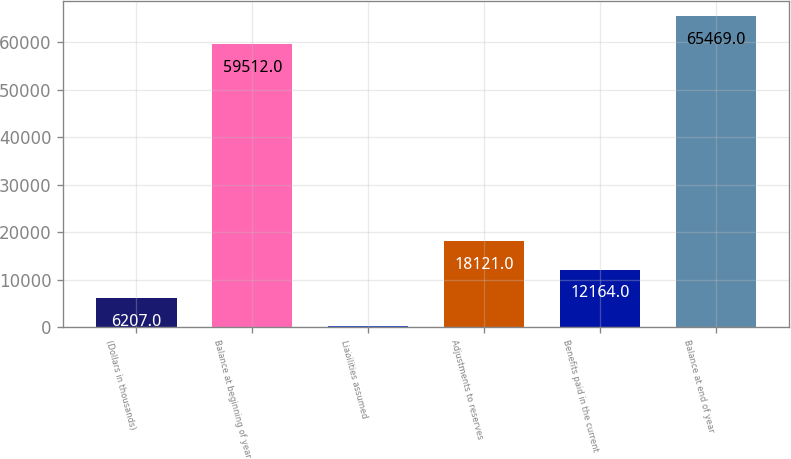<chart> <loc_0><loc_0><loc_500><loc_500><bar_chart><fcel>(Dollars in thousands)<fcel>Balance at beginning of year<fcel>Liabilities assumed<fcel>Adjustments to reserves<fcel>Benefits paid in the current<fcel>Balance at end of year<nl><fcel>6207<fcel>59512<fcel>250<fcel>18121<fcel>12164<fcel>65469<nl></chart> 